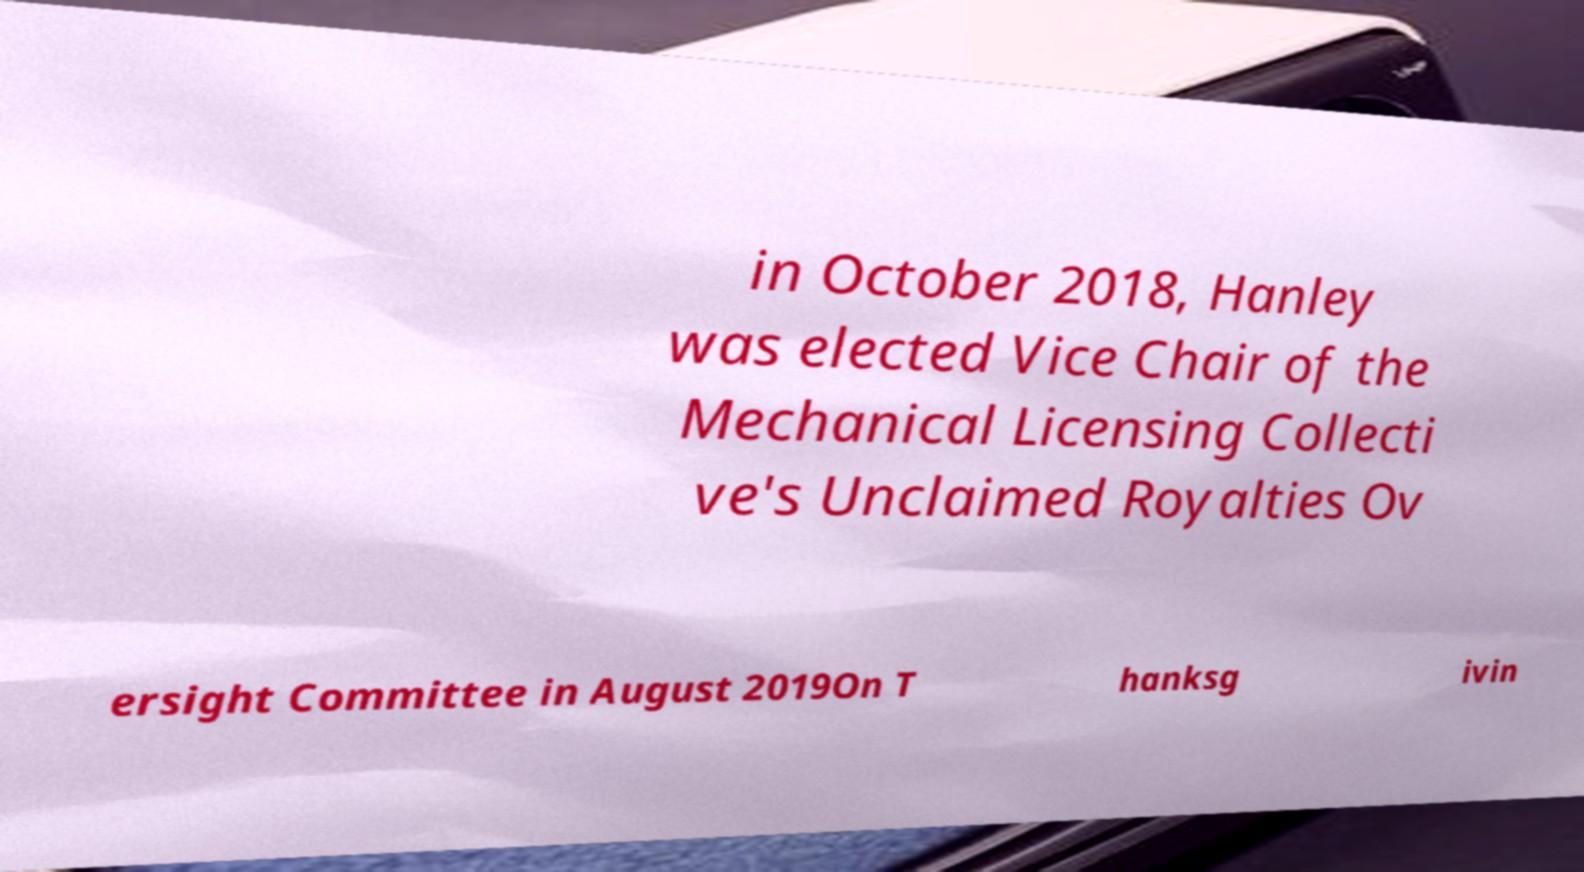Can you accurately transcribe the text from the provided image for me? in October 2018, Hanley was elected Vice Chair of the Mechanical Licensing Collecti ve's Unclaimed Royalties Ov ersight Committee in August 2019On T hanksg ivin 